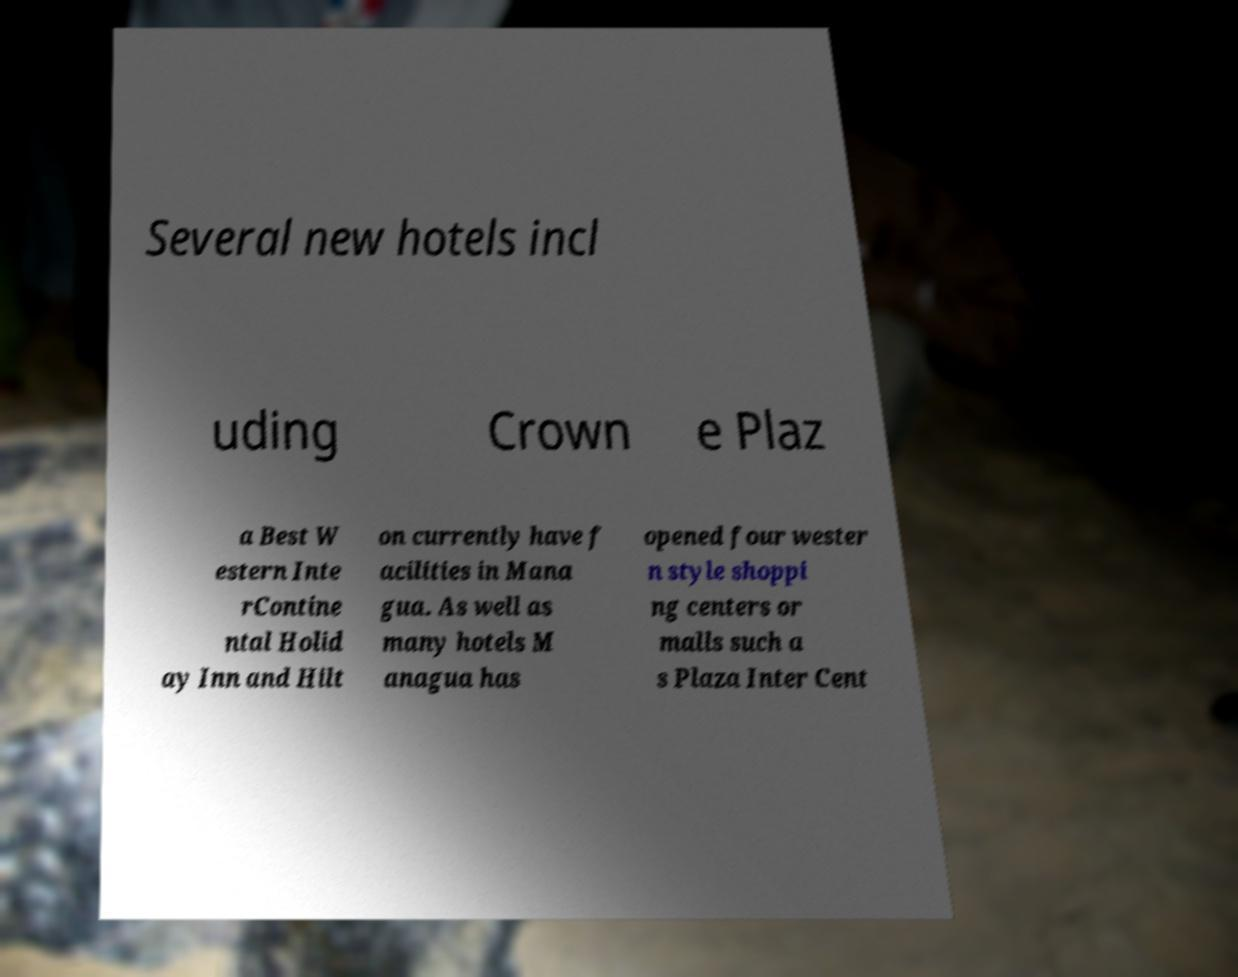Please identify and transcribe the text found in this image. Several new hotels incl uding Crown e Plaz a Best W estern Inte rContine ntal Holid ay Inn and Hilt on currently have f acilities in Mana gua. As well as many hotels M anagua has opened four wester n style shoppi ng centers or malls such a s Plaza Inter Cent 